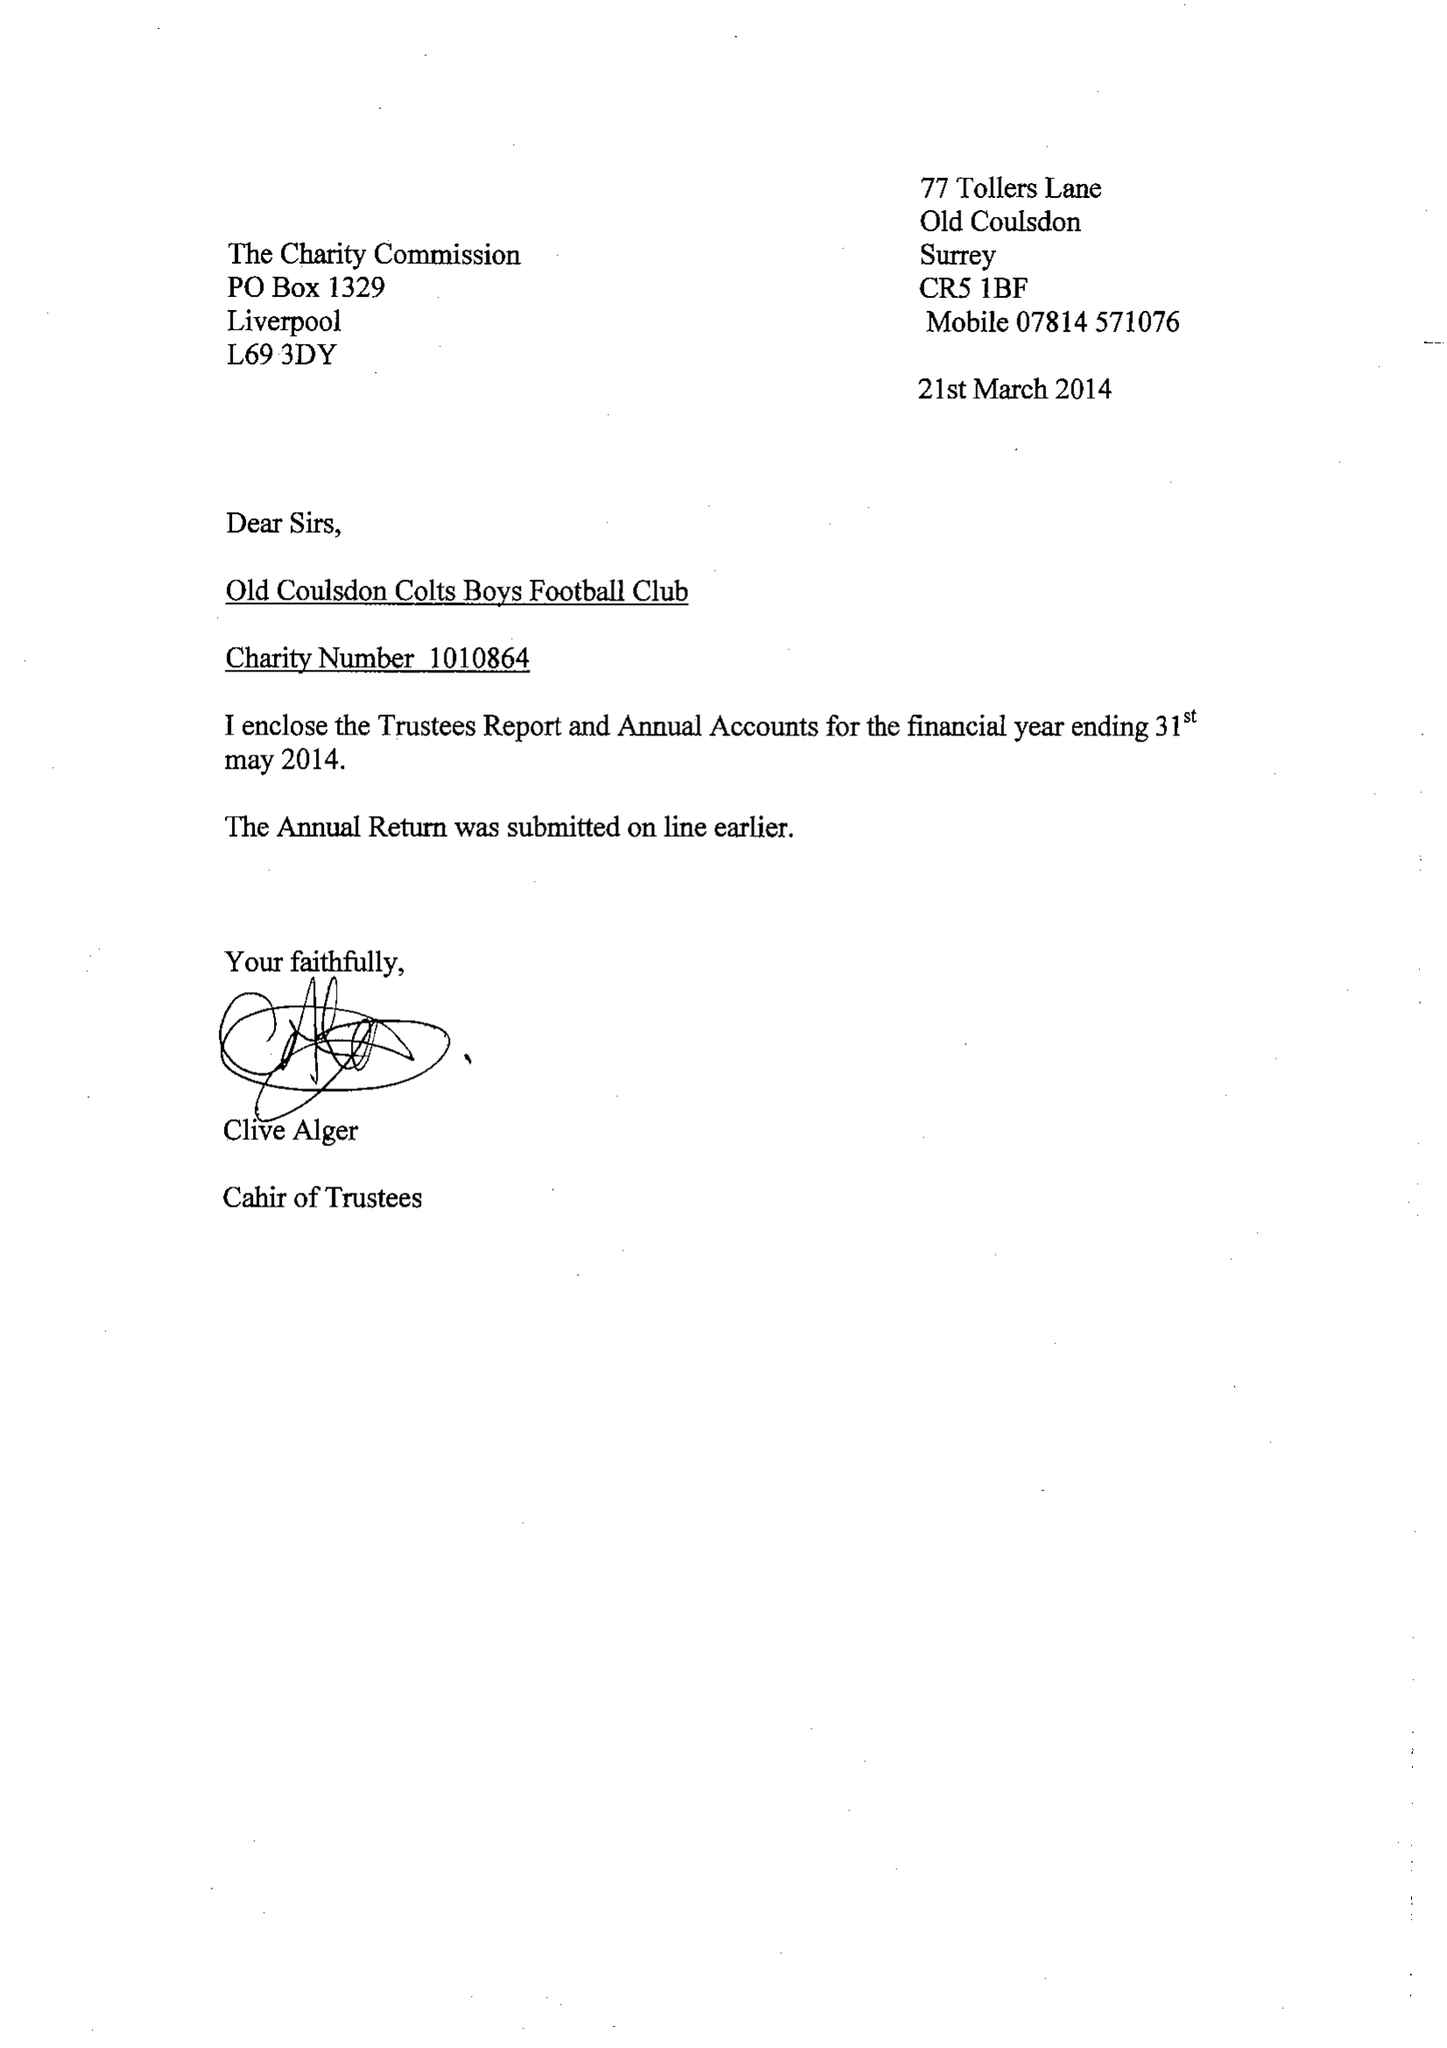What is the value for the address__postcode?
Answer the question using a single word or phrase. CR5 1BF 